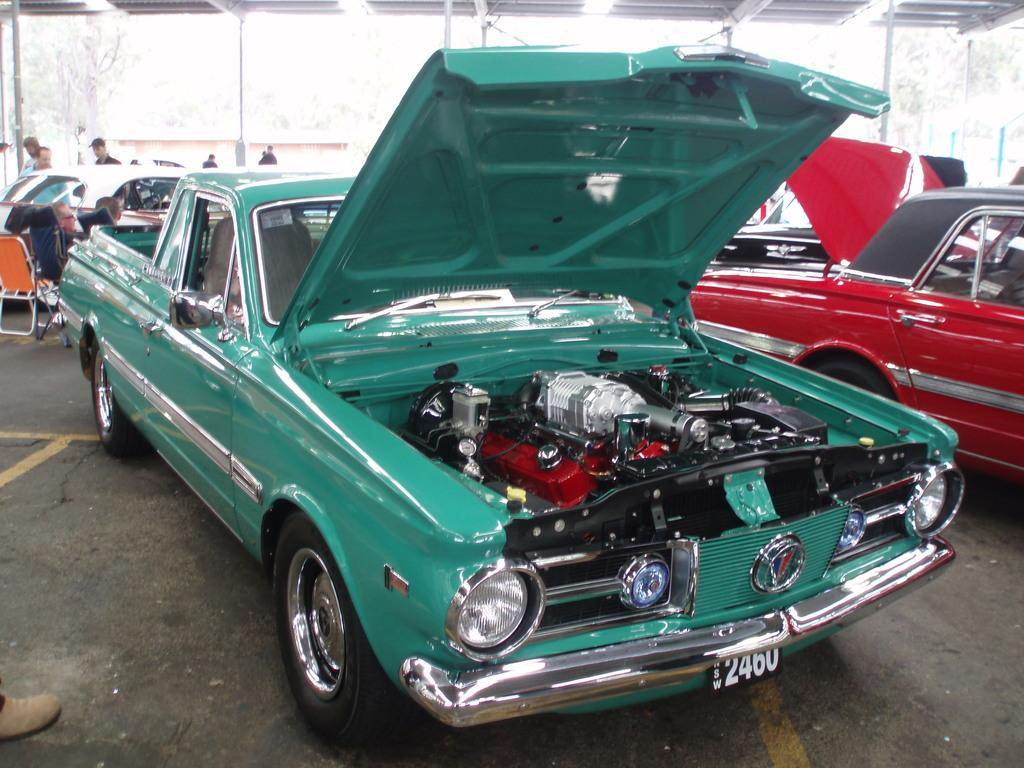What can be seen on the road in the image? There are vehicles on the road in the image. Can you describe the people visible in the image? There are people visible in the image. What objects can be seen in the image besides vehicles and people? There are poles and trees in the image. How would you describe the background of the image? The background of the image appears blurry. Where is the tray located in the image? There is no tray present in the image. What type of jeans are the people wearing in the image? There is no information about the clothing of the people in the image, so we cannot determine if they are wearing jeans or any other type of clothing. 